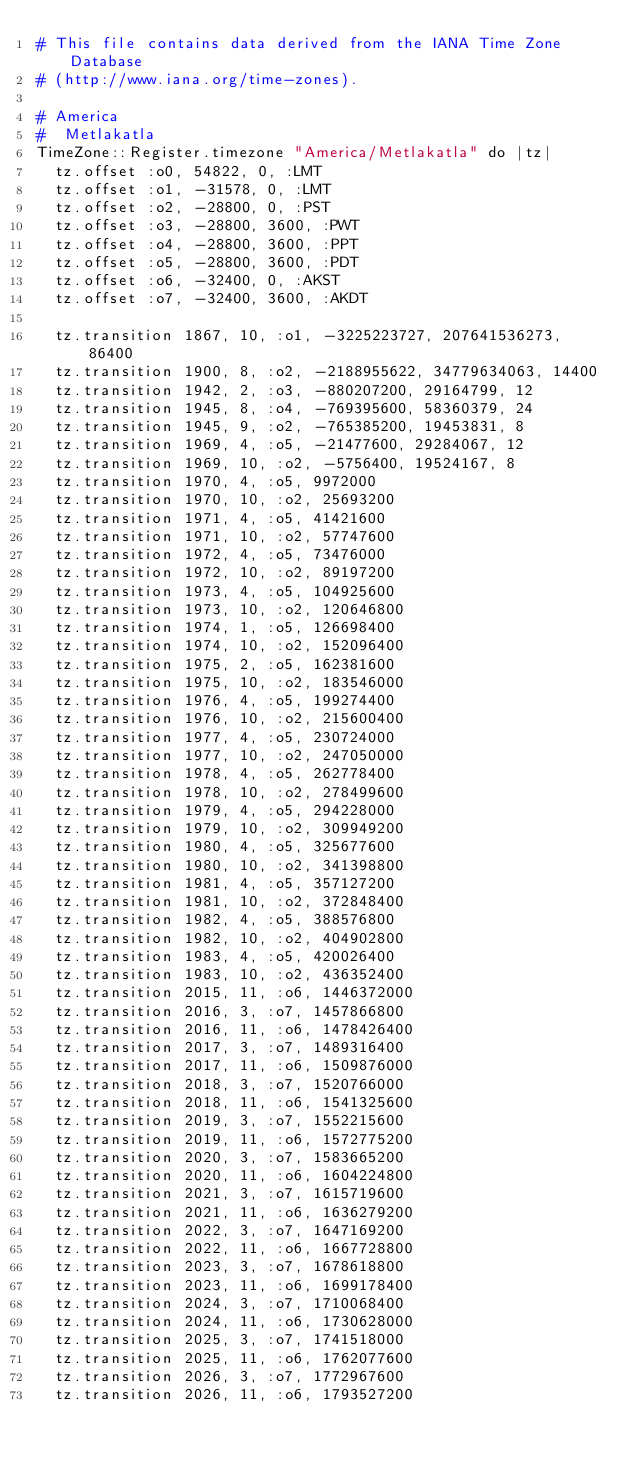<code> <loc_0><loc_0><loc_500><loc_500><_Crystal_># This file contains data derived from the IANA Time Zone Database
# (http://www.iana.org/time-zones).

# America
#  Metlakatla
TimeZone::Register.timezone "America/Metlakatla" do |tz|
  tz.offset :o0, 54822, 0, :LMT
  tz.offset :o1, -31578, 0, :LMT
  tz.offset :o2, -28800, 0, :PST
  tz.offset :o3, -28800, 3600, :PWT
  tz.offset :o4, -28800, 3600, :PPT
  tz.offset :o5, -28800, 3600, :PDT
  tz.offset :o6, -32400, 0, :AKST
  tz.offset :o7, -32400, 3600, :AKDT
  
  tz.transition 1867, 10, :o1, -3225223727, 207641536273, 86400
  tz.transition 1900, 8, :o2, -2188955622, 34779634063, 14400
  tz.transition 1942, 2, :o3, -880207200, 29164799, 12
  tz.transition 1945, 8, :o4, -769395600, 58360379, 24
  tz.transition 1945, 9, :o2, -765385200, 19453831, 8
  tz.transition 1969, 4, :o5, -21477600, 29284067, 12
  tz.transition 1969, 10, :o2, -5756400, 19524167, 8
  tz.transition 1970, 4, :o5, 9972000
  tz.transition 1970, 10, :o2, 25693200
  tz.transition 1971, 4, :o5, 41421600
  tz.transition 1971, 10, :o2, 57747600
  tz.transition 1972, 4, :o5, 73476000
  tz.transition 1972, 10, :o2, 89197200
  tz.transition 1973, 4, :o5, 104925600
  tz.transition 1973, 10, :o2, 120646800
  tz.transition 1974, 1, :o5, 126698400
  tz.transition 1974, 10, :o2, 152096400
  tz.transition 1975, 2, :o5, 162381600
  tz.transition 1975, 10, :o2, 183546000
  tz.transition 1976, 4, :o5, 199274400
  tz.transition 1976, 10, :o2, 215600400
  tz.transition 1977, 4, :o5, 230724000
  tz.transition 1977, 10, :o2, 247050000
  tz.transition 1978, 4, :o5, 262778400
  tz.transition 1978, 10, :o2, 278499600
  tz.transition 1979, 4, :o5, 294228000
  tz.transition 1979, 10, :o2, 309949200
  tz.transition 1980, 4, :o5, 325677600
  tz.transition 1980, 10, :o2, 341398800
  tz.transition 1981, 4, :o5, 357127200
  tz.transition 1981, 10, :o2, 372848400
  tz.transition 1982, 4, :o5, 388576800
  tz.transition 1982, 10, :o2, 404902800
  tz.transition 1983, 4, :o5, 420026400
  tz.transition 1983, 10, :o2, 436352400
  tz.transition 2015, 11, :o6, 1446372000
  tz.transition 2016, 3, :o7, 1457866800
  tz.transition 2016, 11, :o6, 1478426400
  tz.transition 2017, 3, :o7, 1489316400
  tz.transition 2017, 11, :o6, 1509876000
  tz.transition 2018, 3, :o7, 1520766000
  tz.transition 2018, 11, :o6, 1541325600
  tz.transition 2019, 3, :o7, 1552215600
  tz.transition 2019, 11, :o6, 1572775200
  tz.transition 2020, 3, :o7, 1583665200
  tz.transition 2020, 11, :o6, 1604224800
  tz.transition 2021, 3, :o7, 1615719600
  tz.transition 2021, 11, :o6, 1636279200
  tz.transition 2022, 3, :o7, 1647169200
  tz.transition 2022, 11, :o6, 1667728800
  tz.transition 2023, 3, :o7, 1678618800
  tz.transition 2023, 11, :o6, 1699178400
  tz.transition 2024, 3, :o7, 1710068400
  tz.transition 2024, 11, :o6, 1730628000
  tz.transition 2025, 3, :o7, 1741518000
  tz.transition 2025, 11, :o6, 1762077600
  tz.transition 2026, 3, :o7, 1772967600
  tz.transition 2026, 11, :o6, 1793527200</code> 